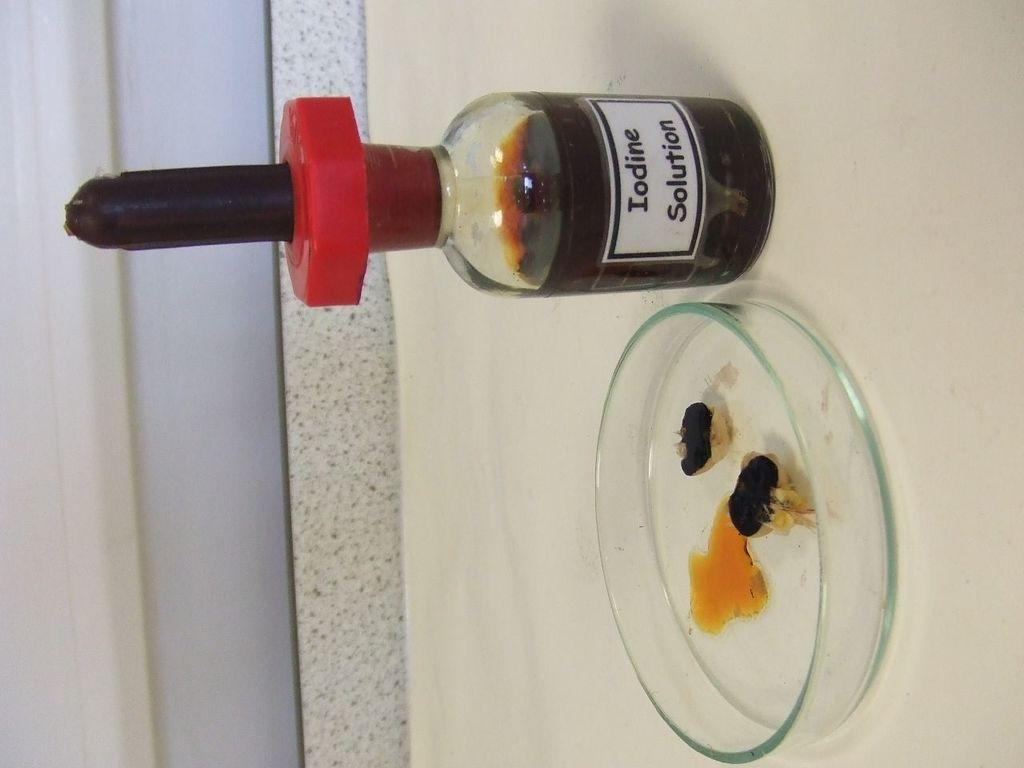What substance is present in the image? There is an iodine solution in the image. What type of container is holding the iodine solution? There is a glass tray in the image. Where is the glass tray located in the image? The glass tray is on the floor in the image. How many boys are lifting the potato in the image? There are no boys or potato present in the image. 